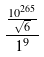Convert formula to latex. <formula><loc_0><loc_0><loc_500><loc_500>\frac { \frac { 1 0 ^ { 2 6 5 } } { \sqrt { 6 } } } { 1 ^ { 9 } }</formula> 